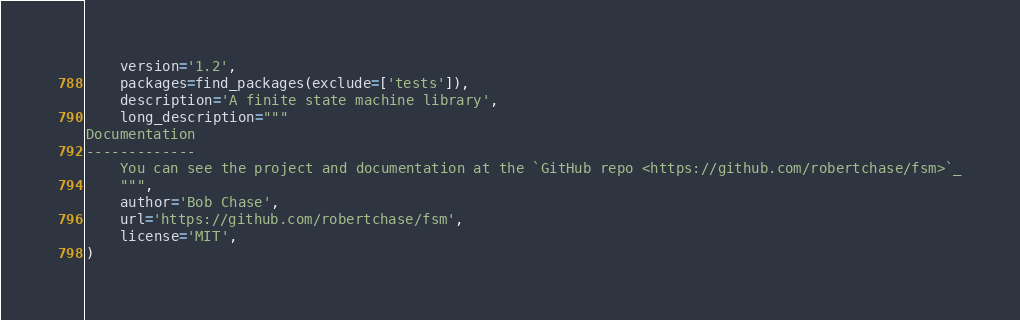Convert code to text. <code><loc_0><loc_0><loc_500><loc_500><_Python_>    version='1.2',
    packages=find_packages(exclude=['tests']),
    description='A finite state machine library',
    long_description="""
Documentation
-------------
    You can see the project and documentation at the `GitHub repo <https://github.com/robertchase/fsm>`_
    """,
    author='Bob Chase',
    url='https://github.com/robertchase/fsm',
    license='MIT',
)
</code> 